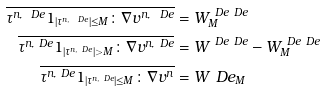<formula> <loc_0><loc_0><loc_500><loc_500>\overline { \tau ^ { n , \ D e } 1 _ { | \tau ^ { n , \ D e } | \leq M } \colon \nabla v ^ { n , \ D e } } & = W ^ { \ D e \ D e } _ { M } \\ \overline { \tau ^ { n , \ D e } 1 _ { | \tau ^ { n , \ D e } | > M } \colon \nabla v ^ { n , \ D e } } & = W ^ { \ D e \ D e } - W ^ { \ D e \ D e } _ { M } \\ \overline { \tau ^ { n , \ D e } 1 _ { | \tau ^ { n , \ D e } | \leq M } \colon \nabla v ^ { n } } & = W ^ { \ } D e _ { M }</formula> 